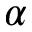Convert formula to latex. <formula><loc_0><loc_0><loc_500><loc_500>\alpha</formula> 